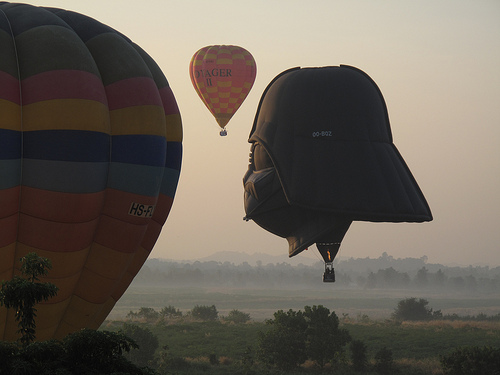<image>
Can you confirm if the darth vader is behind the tree? No. The darth vader is not behind the tree. From this viewpoint, the darth vader appears to be positioned elsewhere in the scene. 